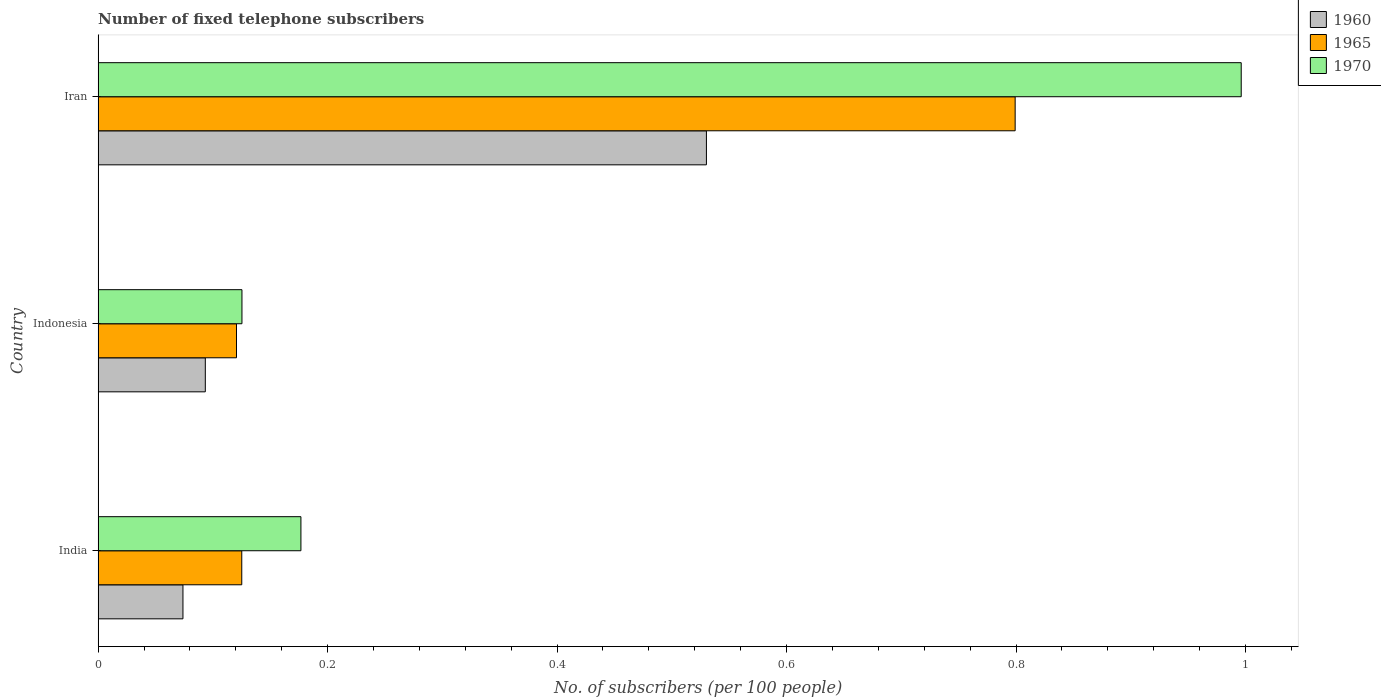How many different coloured bars are there?
Make the answer very short. 3. How many groups of bars are there?
Offer a terse response. 3. How many bars are there on the 2nd tick from the top?
Offer a terse response. 3. What is the label of the 1st group of bars from the top?
Your response must be concise. Iran. What is the number of fixed telephone subscribers in 1970 in Iran?
Your response must be concise. 1. Across all countries, what is the maximum number of fixed telephone subscribers in 1965?
Offer a very short reply. 0.8. Across all countries, what is the minimum number of fixed telephone subscribers in 1965?
Keep it short and to the point. 0.12. In which country was the number of fixed telephone subscribers in 1960 maximum?
Ensure brevity in your answer.  Iran. In which country was the number of fixed telephone subscribers in 1965 minimum?
Make the answer very short. Indonesia. What is the total number of fixed telephone subscribers in 1965 in the graph?
Offer a terse response. 1.05. What is the difference between the number of fixed telephone subscribers in 1960 in India and that in Indonesia?
Your answer should be very brief. -0.02. What is the difference between the number of fixed telephone subscribers in 1970 in India and the number of fixed telephone subscribers in 1960 in Indonesia?
Keep it short and to the point. 0.08. What is the average number of fixed telephone subscribers in 1965 per country?
Provide a succinct answer. 0.35. What is the difference between the number of fixed telephone subscribers in 1960 and number of fixed telephone subscribers in 1965 in Iran?
Your answer should be very brief. -0.27. What is the ratio of the number of fixed telephone subscribers in 1965 in Indonesia to that in Iran?
Make the answer very short. 0.15. Is the number of fixed telephone subscribers in 1960 in India less than that in Indonesia?
Your answer should be very brief. Yes. Is the difference between the number of fixed telephone subscribers in 1960 in India and Iran greater than the difference between the number of fixed telephone subscribers in 1965 in India and Iran?
Keep it short and to the point. Yes. What is the difference between the highest and the second highest number of fixed telephone subscribers in 1960?
Provide a succinct answer. 0.44. What is the difference between the highest and the lowest number of fixed telephone subscribers in 1960?
Make the answer very short. 0.46. In how many countries, is the number of fixed telephone subscribers in 1965 greater than the average number of fixed telephone subscribers in 1965 taken over all countries?
Make the answer very short. 1. What does the 3rd bar from the bottom in Indonesia represents?
Give a very brief answer. 1970. Is it the case that in every country, the sum of the number of fixed telephone subscribers in 1970 and number of fixed telephone subscribers in 1960 is greater than the number of fixed telephone subscribers in 1965?
Keep it short and to the point. Yes. How many bars are there?
Offer a very short reply. 9. How many countries are there in the graph?
Offer a very short reply. 3. Are the values on the major ticks of X-axis written in scientific E-notation?
Provide a succinct answer. No. Does the graph contain any zero values?
Ensure brevity in your answer.  No. Does the graph contain grids?
Ensure brevity in your answer.  No. How many legend labels are there?
Your answer should be very brief. 3. How are the legend labels stacked?
Your answer should be very brief. Vertical. What is the title of the graph?
Make the answer very short. Number of fixed telephone subscribers. Does "1965" appear as one of the legend labels in the graph?
Provide a short and direct response. Yes. What is the label or title of the X-axis?
Offer a terse response. No. of subscribers (per 100 people). What is the No. of subscribers (per 100 people) of 1960 in India?
Make the answer very short. 0.07. What is the No. of subscribers (per 100 people) of 1965 in India?
Offer a very short reply. 0.13. What is the No. of subscribers (per 100 people) of 1970 in India?
Your answer should be very brief. 0.18. What is the No. of subscribers (per 100 people) in 1960 in Indonesia?
Provide a short and direct response. 0.09. What is the No. of subscribers (per 100 people) in 1965 in Indonesia?
Offer a terse response. 0.12. What is the No. of subscribers (per 100 people) in 1970 in Indonesia?
Offer a terse response. 0.13. What is the No. of subscribers (per 100 people) in 1960 in Iran?
Ensure brevity in your answer.  0.53. What is the No. of subscribers (per 100 people) of 1965 in Iran?
Provide a succinct answer. 0.8. What is the No. of subscribers (per 100 people) of 1970 in Iran?
Offer a terse response. 1. Across all countries, what is the maximum No. of subscribers (per 100 people) in 1960?
Your answer should be very brief. 0.53. Across all countries, what is the maximum No. of subscribers (per 100 people) in 1965?
Your answer should be very brief. 0.8. Across all countries, what is the maximum No. of subscribers (per 100 people) of 1970?
Your answer should be compact. 1. Across all countries, what is the minimum No. of subscribers (per 100 people) in 1960?
Offer a very short reply. 0.07. Across all countries, what is the minimum No. of subscribers (per 100 people) of 1965?
Provide a short and direct response. 0.12. Across all countries, what is the minimum No. of subscribers (per 100 people) in 1970?
Your answer should be very brief. 0.13. What is the total No. of subscribers (per 100 people) of 1960 in the graph?
Ensure brevity in your answer.  0.7. What is the total No. of subscribers (per 100 people) in 1965 in the graph?
Your response must be concise. 1.04. What is the total No. of subscribers (per 100 people) of 1970 in the graph?
Provide a short and direct response. 1.3. What is the difference between the No. of subscribers (per 100 people) of 1960 in India and that in Indonesia?
Give a very brief answer. -0.02. What is the difference between the No. of subscribers (per 100 people) of 1965 in India and that in Indonesia?
Ensure brevity in your answer.  0. What is the difference between the No. of subscribers (per 100 people) in 1970 in India and that in Indonesia?
Make the answer very short. 0.05. What is the difference between the No. of subscribers (per 100 people) of 1960 in India and that in Iran?
Your response must be concise. -0.46. What is the difference between the No. of subscribers (per 100 people) in 1965 in India and that in Iran?
Your answer should be compact. -0.67. What is the difference between the No. of subscribers (per 100 people) of 1970 in India and that in Iran?
Keep it short and to the point. -0.82. What is the difference between the No. of subscribers (per 100 people) of 1960 in Indonesia and that in Iran?
Offer a terse response. -0.44. What is the difference between the No. of subscribers (per 100 people) of 1965 in Indonesia and that in Iran?
Provide a short and direct response. -0.68. What is the difference between the No. of subscribers (per 100 people) of 1970 in Indonesia and that in Iran?
Make the answer very short. -0.87. What is the difference between the No. of subscribers (per 100 people) of 1960 in India and the No. of subscribers (per 100 people) of 1965 in Indonesia?
Offer a terse response. -0.05. What is the difference between the No. of subscribers (per 100 people) in 1960 in India and the No. of subscribers (per 100 people) in 1970 in Indonesia?
Your response must be concise. -0.05. What is the difference between the No. of subscribers (per 100 people) of 1965 in India and the No. of subscribers (per 100 people) of 1970 in Indonesia?
Your response must be concise. -0. What is the difference between the No. of subscribers (per 100 people) in 1960 in India and the No. of subscribers (per 100 people) in 1965 in Iran?
Keep it short and to the point. -0.73. What is the difference between the No. of subscribers (per 100 people) in 1960 in India and the No. of subscribers (per 100 people) in 1970 in Iran?
Offer a terse response. -0.92. What is the difference between the No. of subscribers (per 100 people) in 1965 in India and the No. of subscribers (per 100 people) in 1970 in Iran?
Your answer should be very brief. -0.87. What is the difference between the No. of subscribers (per 100 people) of 1960 in Indonesia and the No. of subscribers (per 100 people) of 1965 in Iran?
Your answer should be compact. -0.71. What is the difference between the No. of subscribers (per 100 people) in 1960 in Indonesia and the No. of subscribers (per 100 people) in 1970 in Iran?
Your response must be concise. -0.9. What is the difference between the No. of subscribers (per 100 people) of 1965 in Indonesia and the No. of subscribers (per 100 people) of 1970 in Iran?
Provide a short and direct response. -0.88. What is the average No. of subscribers (per 100 people) of 1960 per country?
Keep it short and to the point. 0.23. What is the average No. of subscribers (per 100 people) of 1965 per country?
Your answer should be very brief. 0.35. What is the average No. of subscribers (per 100 people) of 1970 per country?
Ensure brevity in your answer.  0.43. What is the difference between the No. of subscribers (per 100 people) in 1960 and No. of subscribers (per 100 people) in 1965 in India?
Offer a very short reply. -0.05. What is the difference between the No. of subscribers (per 100 people) in 1960 and No. of subscribers (per 100 people) in 1970 in India?
Your response must be concise. -0.1. What is the difference between the No. of subscribers (per 100 people) of 1965 and No. of subscribers (per 100 people) of 1970 in India?
Offer a terse response. -0.05. What is the difference between the No. of subscribers (per 100 people) of 1960 and No. of subscribers (per 100 people) of 1965 in Indonesia?
Offer a terse response. -0.03. What is the difference between the No. of subscribers (per 100 people) of 1960 and No. of subscribers (per 100 people) of 1970 in Indonesia?
Ensure brevity in your answer.  -0.03. What is the difference between the No. of subscribers (per 100 people) of 1965 and No. of subscribers (per 100 people) of 1970 in Indonesia?
Offer a very short reply. -0. What is the difference between the No. of subscribers (per 100 people) in 1960 and No. of subscribers (per 100 people) in 1965 in Iran?
Your answer should be very brief. -0.27. What is the difference between the No. of subscribers (per 100 people) in 1960 and No. of subscribers (per 100 people) in 1970 in Iran?
Provide a succinct answer. -0.47. What is the difference between the No. of subscribers (per 100 people) of 1965 and No. of subscribers (per 100 people) of 1970 in Iran?
Your answer should be compact. -0.2. What is the ratio of the No. of subscribers (per 100 people) in 1960 in India to that in Indonesia?
Keep it short and to the point. 0.79. What is the ratio of the No. of subscribers (per 100 people) in 1965 in India to that in Indonesia?
Provide a short and direct response. 1.04. What is the ratio of the No. of subscribers (per 100 people) of 1970 in India to that in Indonesia?
Offer a terse response. 1.41. What is the ratio of the No. of subscribers (per 100 people) in 1960 in India to that in Iran?
Provide a short and direct response. 0.14. What is the ratio of the No. of subscribers (per 100 people) in 1965 in India to that in Iran?
Provide a succinct answer. 0.16. What is the ratio of the No. of subscribers (per 100 people) of 1970 in India to that in Iran?
Make the answer very short. 0.18. What is the ratio of the No. of subscribers (per 100 people) in 1960 in Indonesia to that in Iran?
Your answer should be compact. 0.18. What is the ratio of the No. of subscribers (per 100 people) of 1965 in Indonesia to that in Iran?
Provide a succinct answer. 0.15. What is the ratio of the No. of subscribers (per 100 people) in 1970 in Indonesia to that in Iran?
Offer a very short reply. 0.13. What is the difference between the highest and the second highest No. of subscribers (per 100 people) of 1960?
Your answer should be very brief. 0.44. What is the difference between the highest and the second highest No. of subscribers (per 100 people) in 1965?
Offer a very short reply. 0.67. What is the difference between the highest and the second highest No. of subscribers (per 100 people) in 1970?
Give a very brief answer. 0.82. What is the difference between the highest and the lowest No. of subscribers (per 100 people) of 1960?
Keep it short and to the point. 0.46. What is the difference between the highest and the lowest No. of subscribers (per 100 people) of 1965?
Your answer should be very brief. 0.68. What is the difference between the highest and the lowest No. of subscribers (per 100 people) in 1970?
Ensure brevity in your answer.  0.87. 